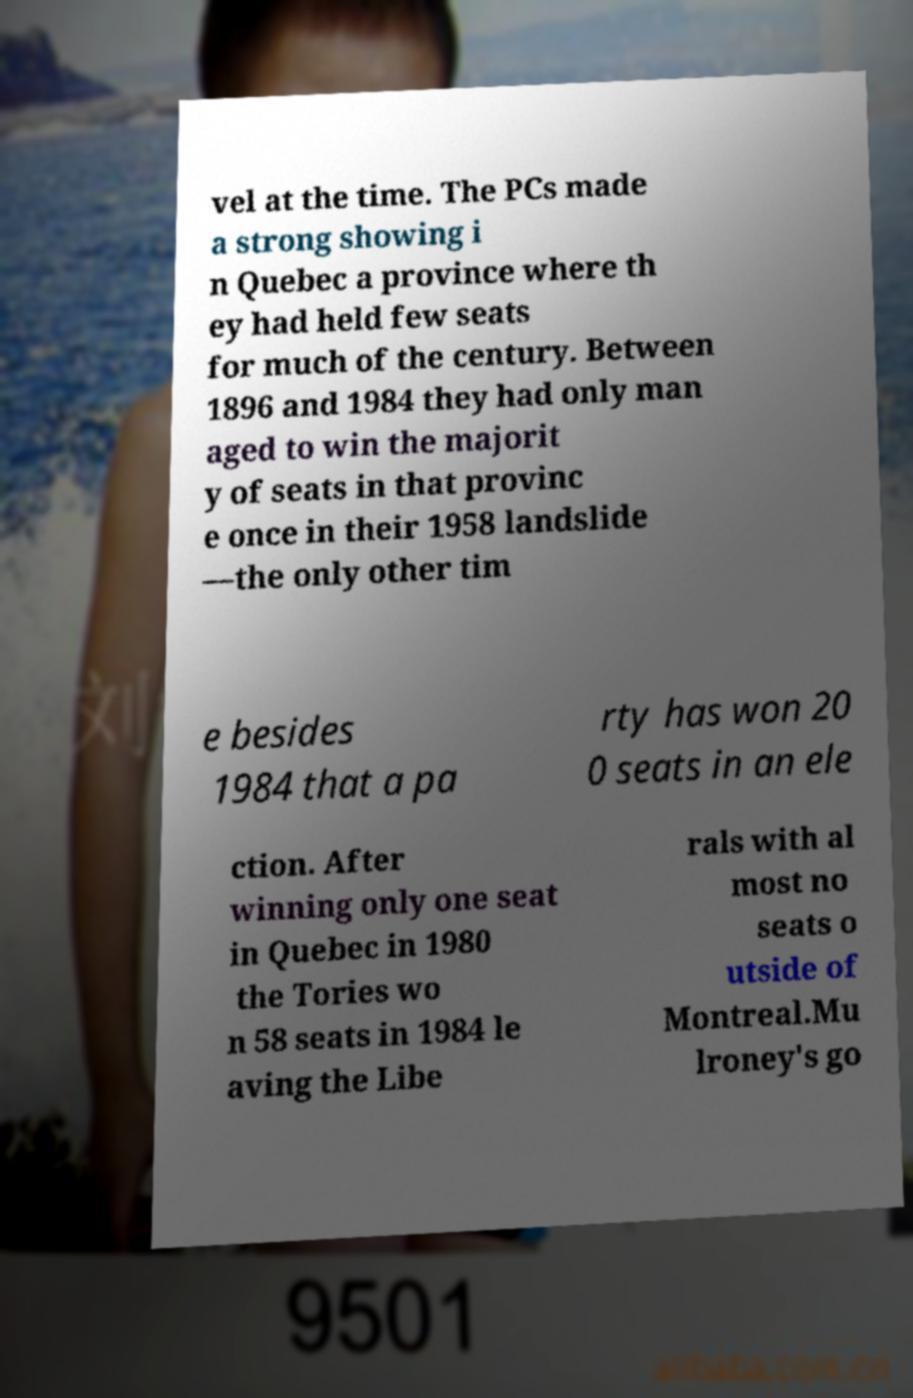Could you extract and type out the text from this image? vel at the time. The PCs made a strong showing i n Quebec a province where th ey had held few seats for much of the century. Between 1896 and 1984 they had only man aged to win the majorit y of seats in that provinc e once in their 1958 landslide —the only other tim e besides 1984 that a pa rty has won 20 0 seats in an ele ction. After winning only one seat in Quebec in 1980 the Tories wo n 58 seats in 1984 le aving the Libe rals with al most no seats o utside of Montreal.Mu lroney's go 